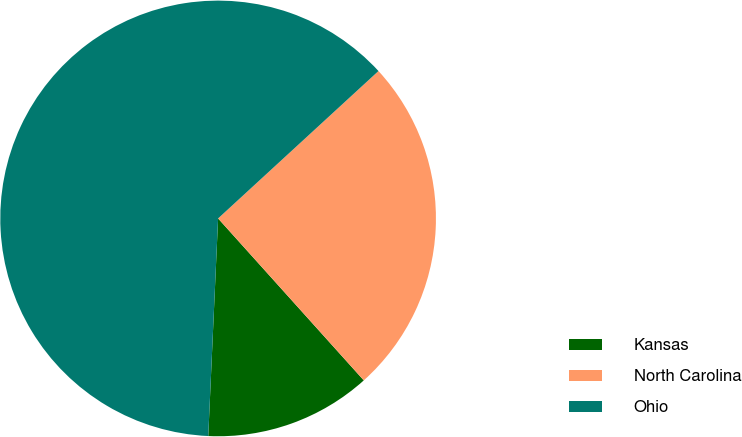Convert chart to OTSL. <chart><loc_0><loc_0><loc_500><loc_500><pie_chart><fcel>Kansas<fcel>North Carolina<fcel>Ohio<nl><fcel>12.38%<fcel>25.17%<fcel>62.45%<nl></chart> 